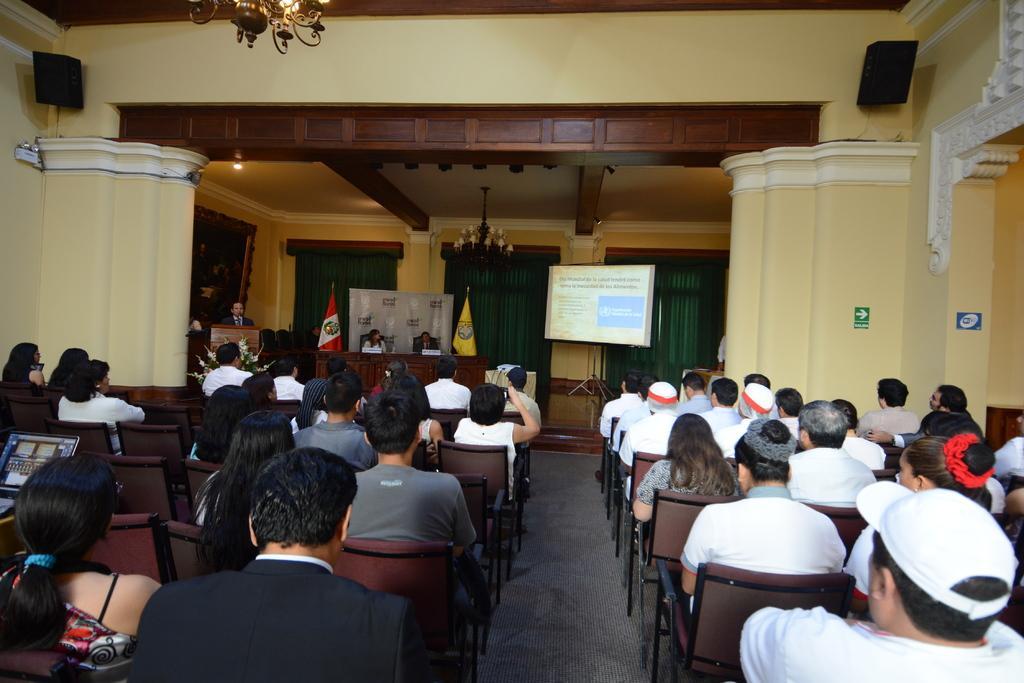Can you describe this image briefly? In this image we can see the people sitting on the chairs which are on the floor. We can also see the walls, display screen, banner, flags and also the lights. We can see the curtains, ceiling, podium, table and also the stage. We can also see the sound boxes. 